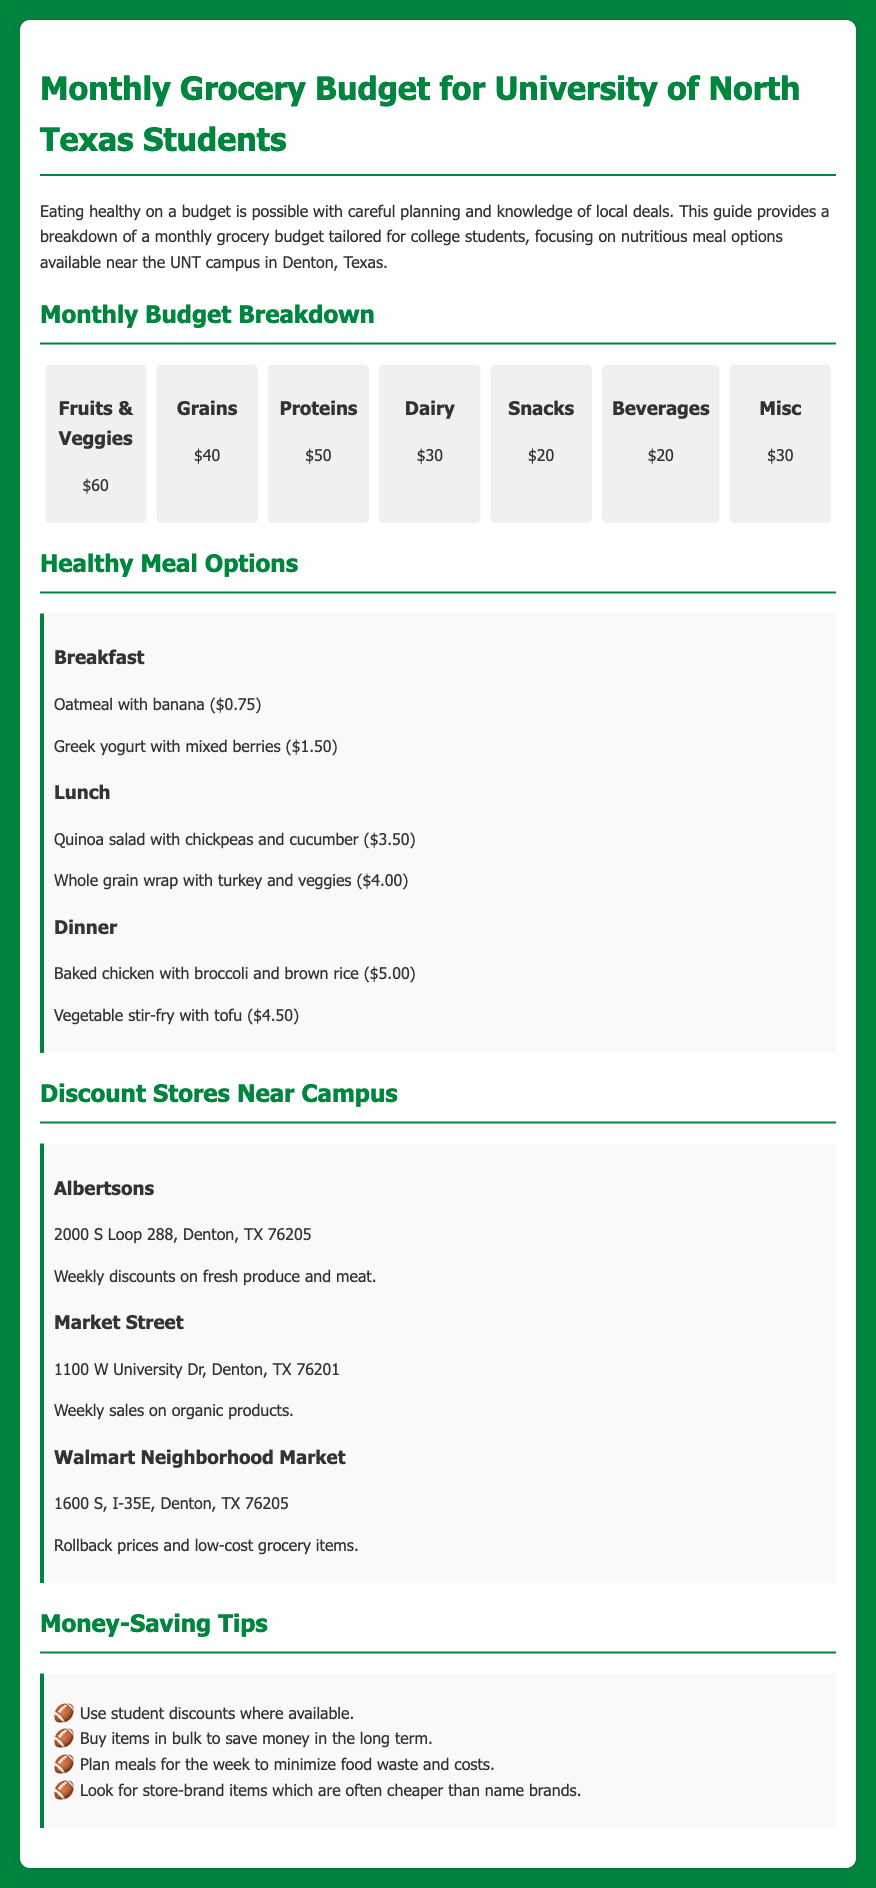What is the total cost allocated for Fruits & Veggies? The document specifies that the budget for Fruits & Veggies is $60.
Answer: $60 How much is allocated for Proteins? The budget allocation for Proteins in the document is stated to be $50.
Answer: $50 What is one breakfast option listed? The document contains breakfast options, one of which is "Oatmeal with banana."
Answer: Oatmeal with banana What type of store is Albertsons? The document describes Albertsons as a discount store that offers weekly discounts.
Answer: Discount store How much is a Quinoa salad with chickpeas and cucumber? The document lists the cost of a Quinoa salad with chickpeas and cucumber as $3.50.
Answer: $3.50 Which store offers rollback prices? The document indicates that Walmart Neighborhood Market offers rollback prices and low-cost grocery items.
Answer: Walmart Neighborhood Market What is one money-saving tip provided? A money-saving tip mentioned is "Buy items in bulk to save money in the long term."
Answer: Buy items in bulk How much is budgeted for Dairy? The budget for Dairy is specified as $30 in the document.
Answer: $30 What is the address of Market Street? The document states the address of Market Street as 1100 W University Dr, Denton, TX 76201.
Answer: 1100 W University Dr, Denton, TX 76201 